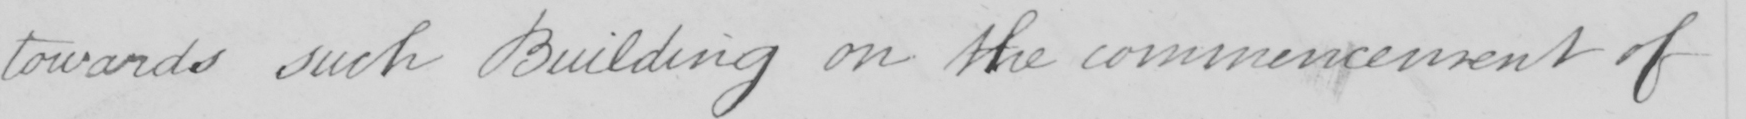Transcribe the text shown in this historical manuscript line. towards such Building on the commencement of 